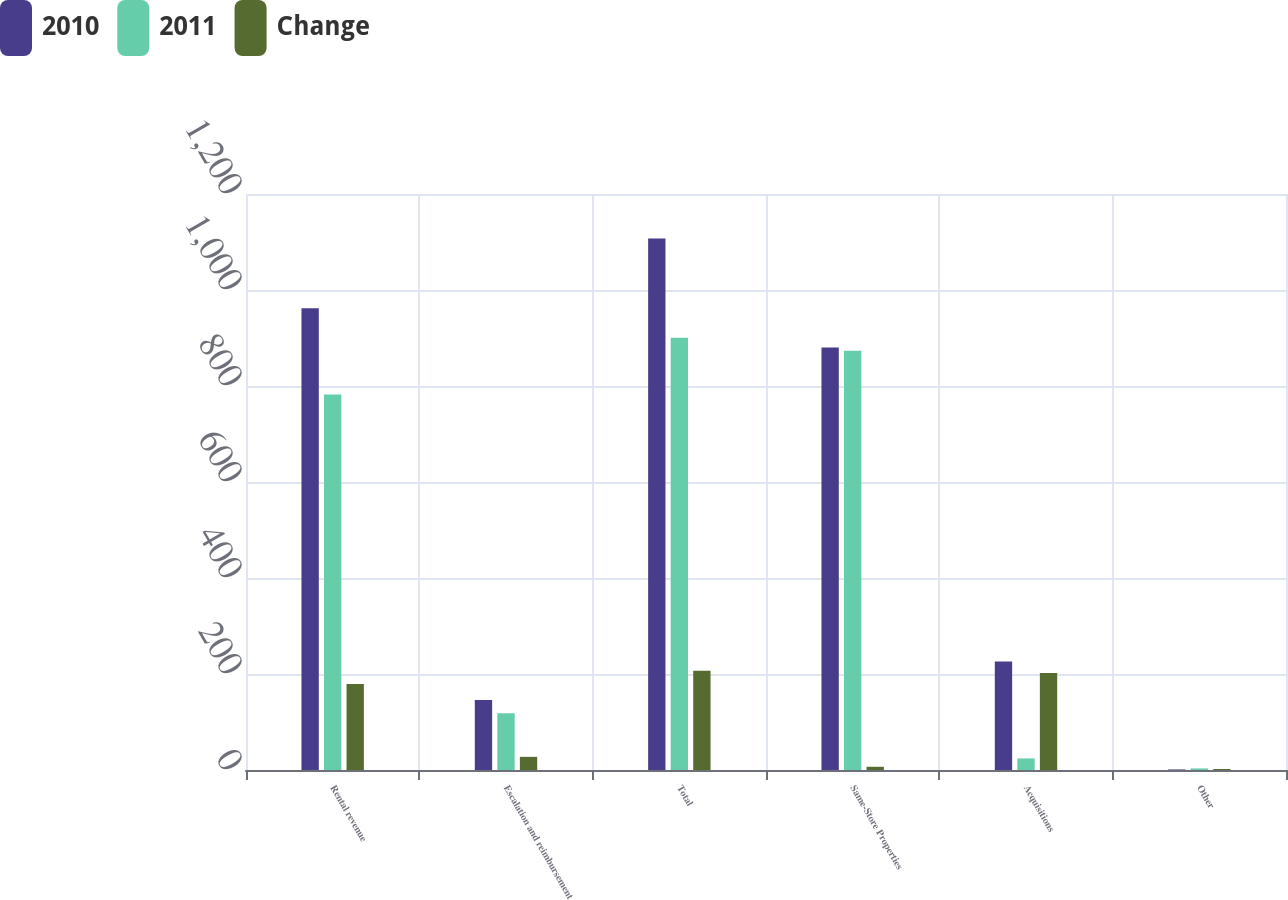<chart> <loc_0><loc_0><loc_500><loc_500><stacked_bar_chart><ecel><fcel>Rental revenue<fcel>Escalation and reimbursement<fcel>Total<fcel>Same-Store Properties<fcel>Acquisitions<fcel>Other<nl><fcel>2010<fcel>961.9<fcel>145.6<fcel>1107.5<fcel>880<fcel>226.3<fcel>1.2<nl><fcel>2011<fcel>782.5<fcel>118.2<fcel>900.7<fcel>873.3<fcel>24.1<fcel>3.3<nl><fcel>Change<fcel>179.4<fcel>27.4<fcel>206.8<fcel>6.7<fcel>202.2<fcel>2.1<nl></chart> 